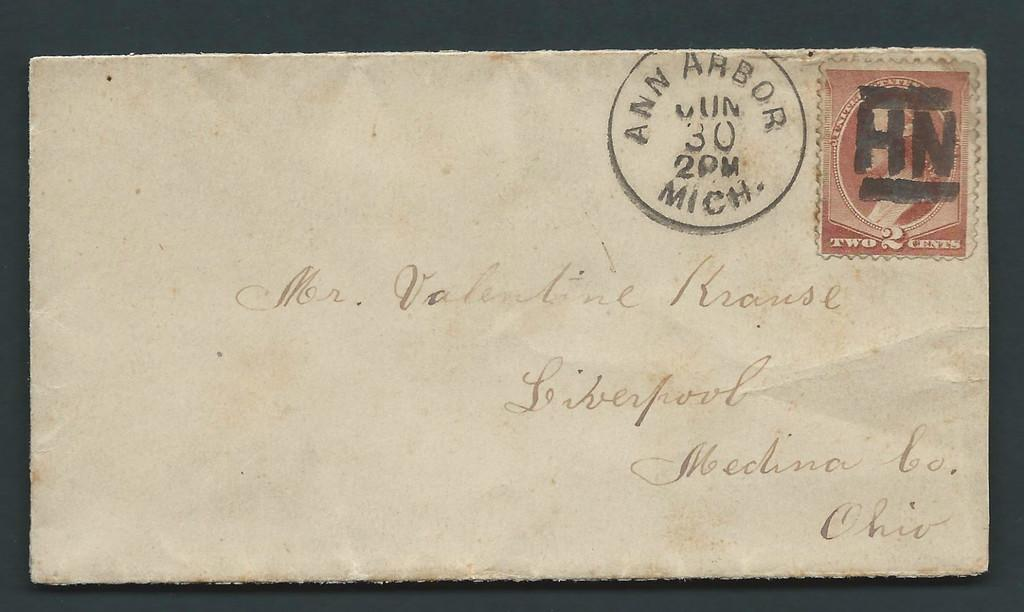<image>
Render a clear and concise summary of the photo. A very old envelope postmarked Ann Arbor, Michigan. 